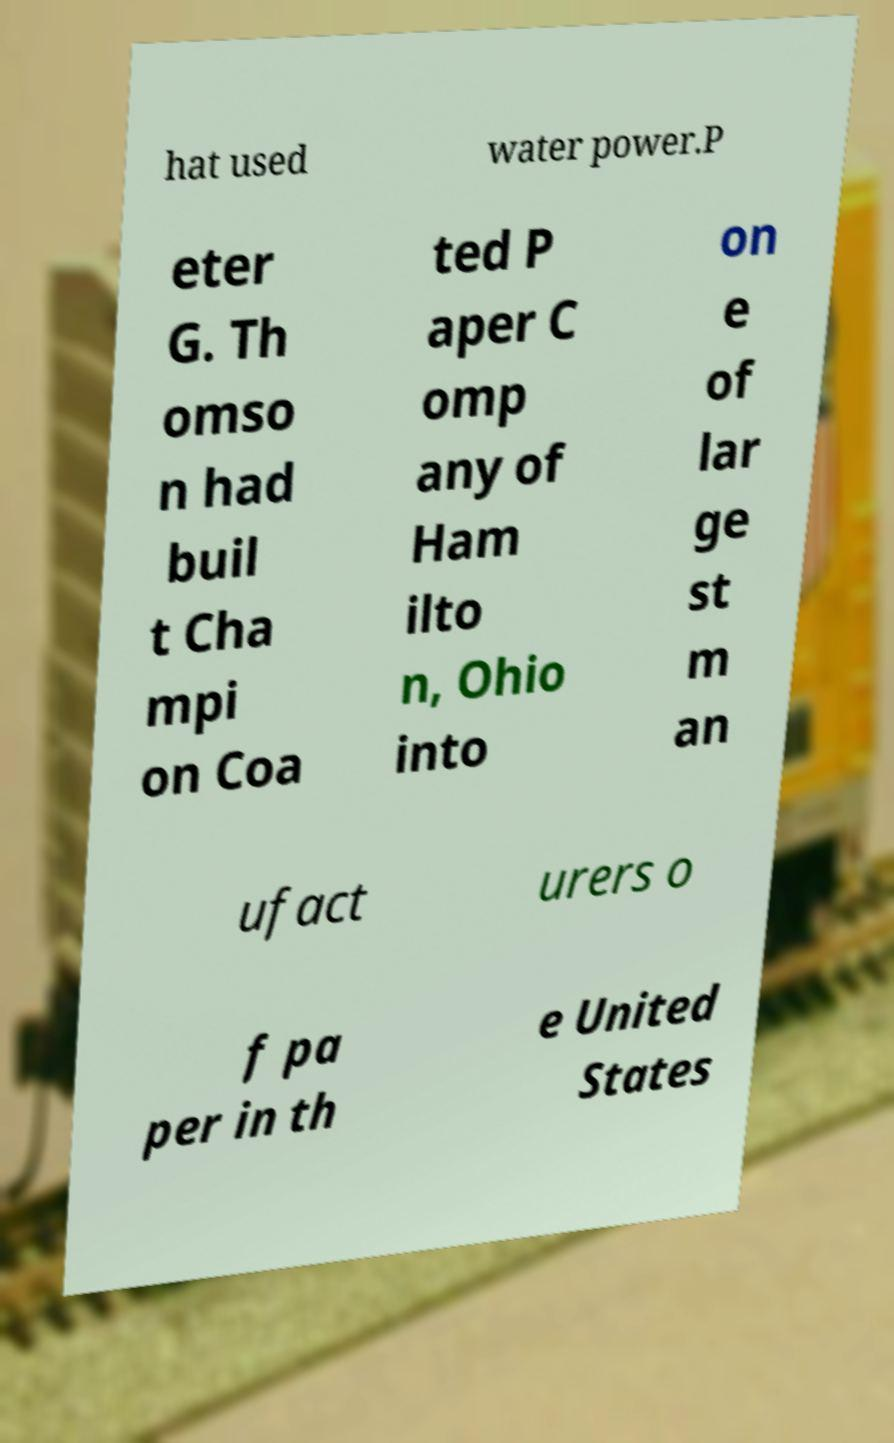What messages or text are displayed in this image? I need them in a readable, typed format. hat used water power.P eter G. Th omso n had buil t Cha mpi on Coa ted P aper C omp any of Ham ilto n, Ohio into on e of lar ge st m an ufact urers o f pa per in th e United States 